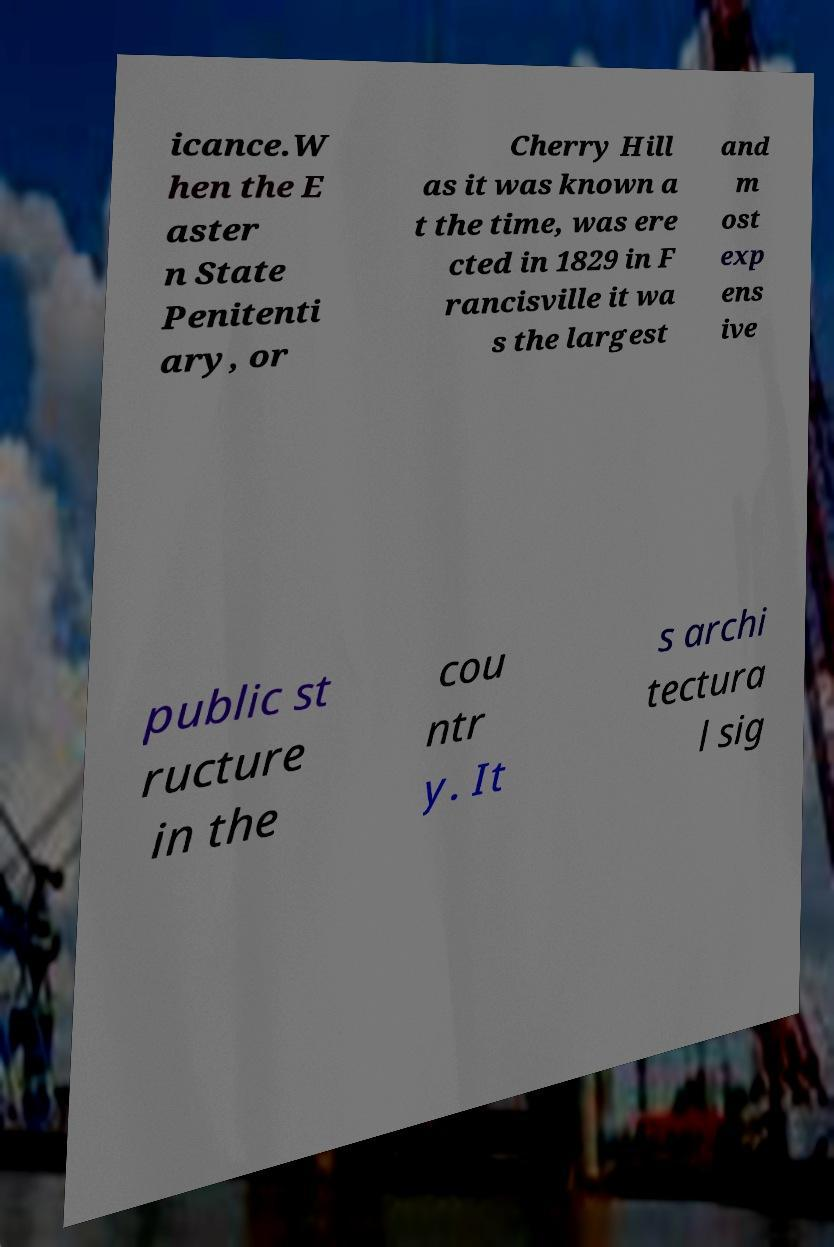There's text embedded in this image that I need extracted. Can you transcribe it verbatim? icance.W hen the E aster n State Penitenti ary, or Cherry Hill as it was known a t the time, was ere cted in 1829 in F rancisville it wa s the largest and m ost exp ens ive public st ructure in the cou ntr y. It s archi tectura l sig 